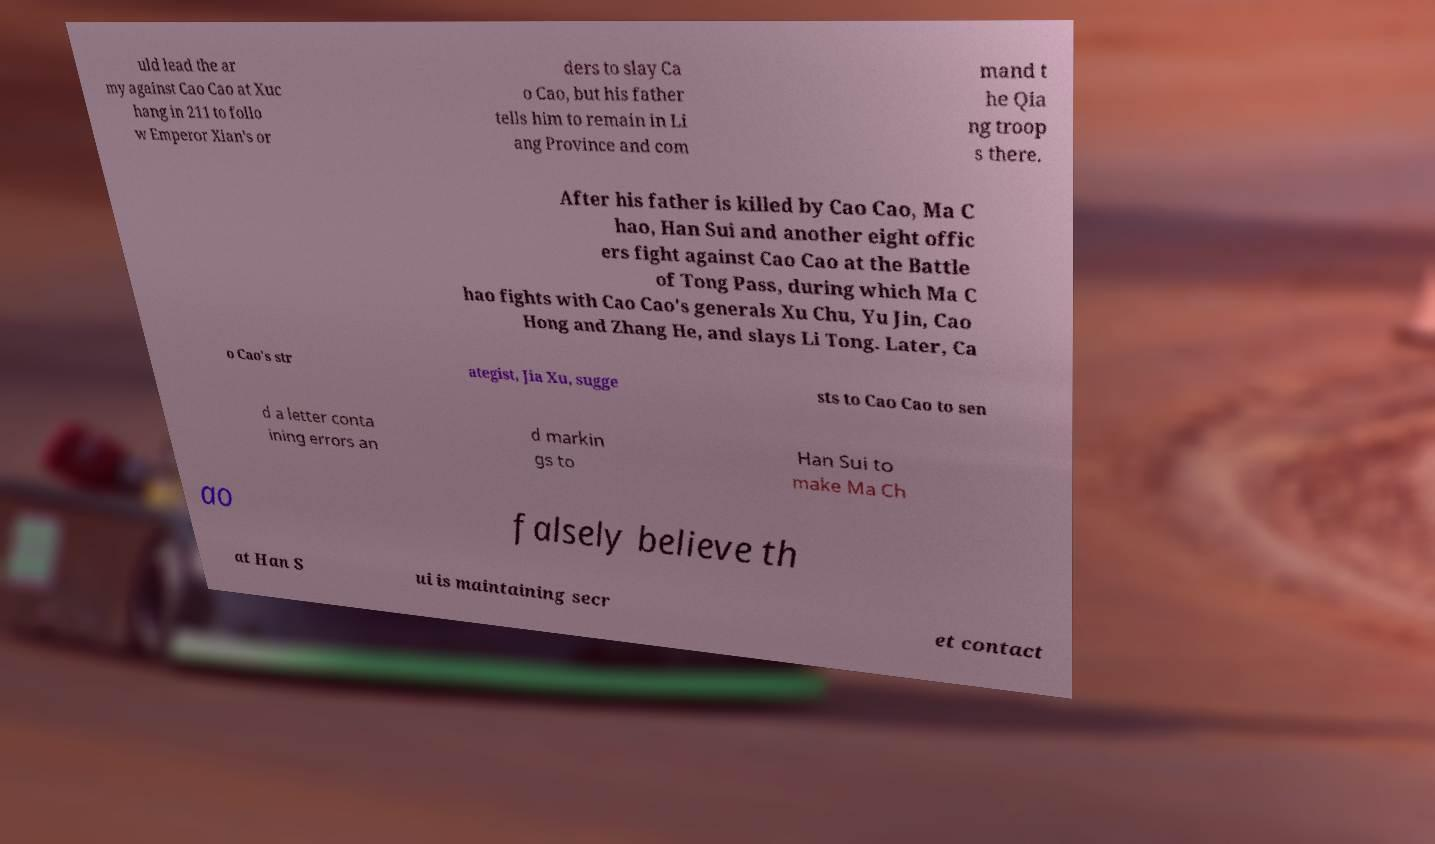For documentation purposes, I need the text within this image transcribed. Could you provide that? uld lead the ar my against Cao Cao at Xuc hang in 211 to follo w Emperor Xian's or ders to slay Ca o Cao, but his father tells him to remain in Li ang Province and com mand t he Qia ng troop s there. After his father is killed by Cao Cao, Ma C hao, Han Sui and another eight offic ers fight against Cao Cao at the Battle of Tong Pass, during which Ma C hao fights with Cao Cao's generals Xu Chu, Yu Jin, Cao Hong and Zhang He, and slays Li Tong. Later, Ca o Cao's str ategist, Jia Xu, sugge sts to Cao Cao to sen d a letter conta ining errors an d markin gs to Han Sui to make Ma Ch ao falsely believe th at Han S ui is maintaining secr et contact 